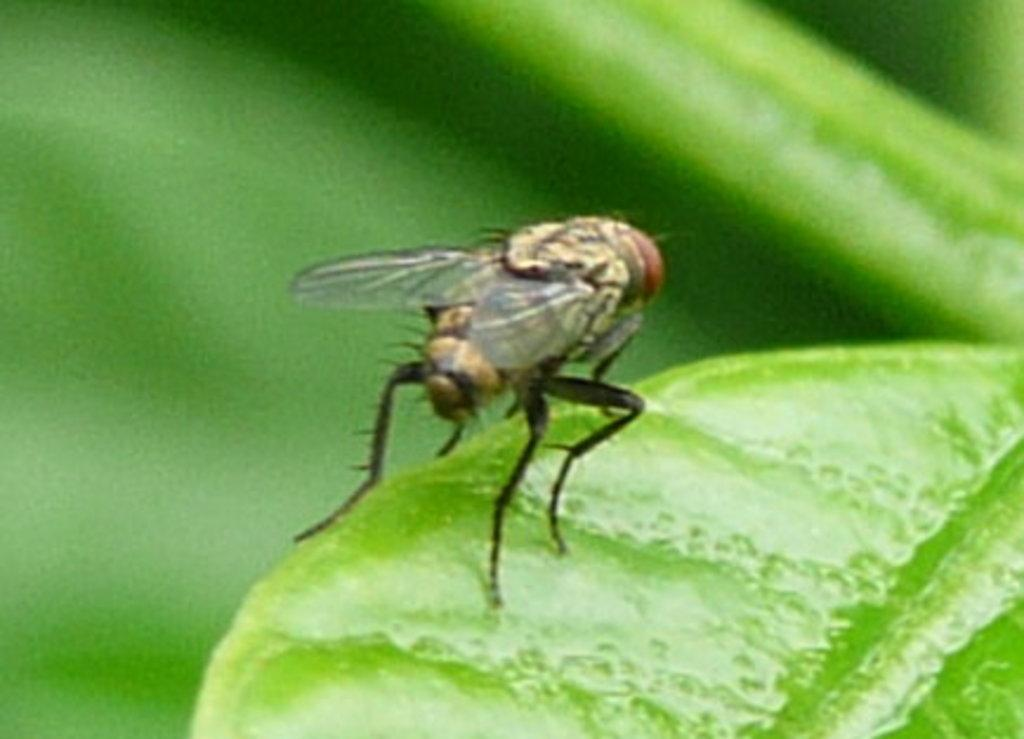What is the main subject of the image? The main subject of the image is an insect on a leaf. Can you describe the background of the image? The background of the image is blurred. What type of footwear can be seen in the bedroom in the image? There is no bedroom or footwear present in the image; it features an insect on a leaf with a blurred background. 